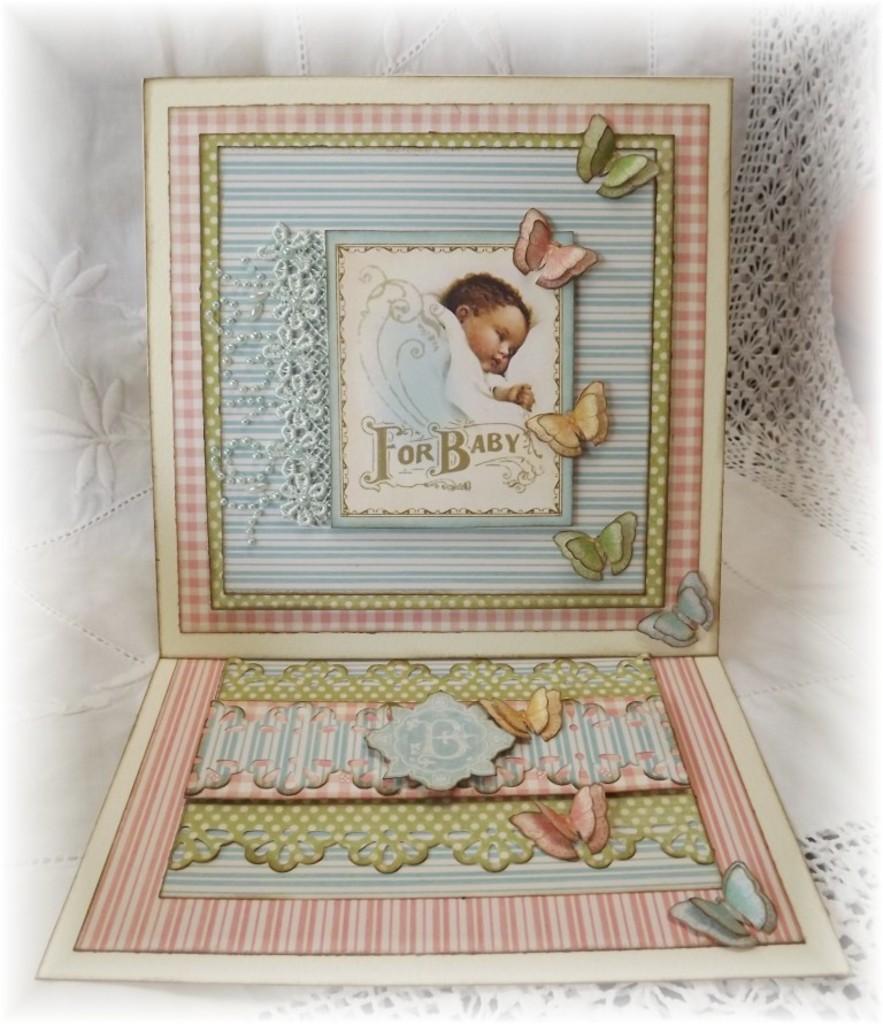What is the main subject of the photos in the image? The photos contain images of a baby and a butterfly. What else can be seen on the photos besides the images? The photos contain designs and text. How are the photos arranged in the image? The photos are placed on a cloth in the image. What type of pancake can be seen in the background of the image? There is no pancake present in the image; it features photos on a cloth. Can you tell me how many dolls are visible in the image? There are no dolls present in the image; it features photos on a cloth. 